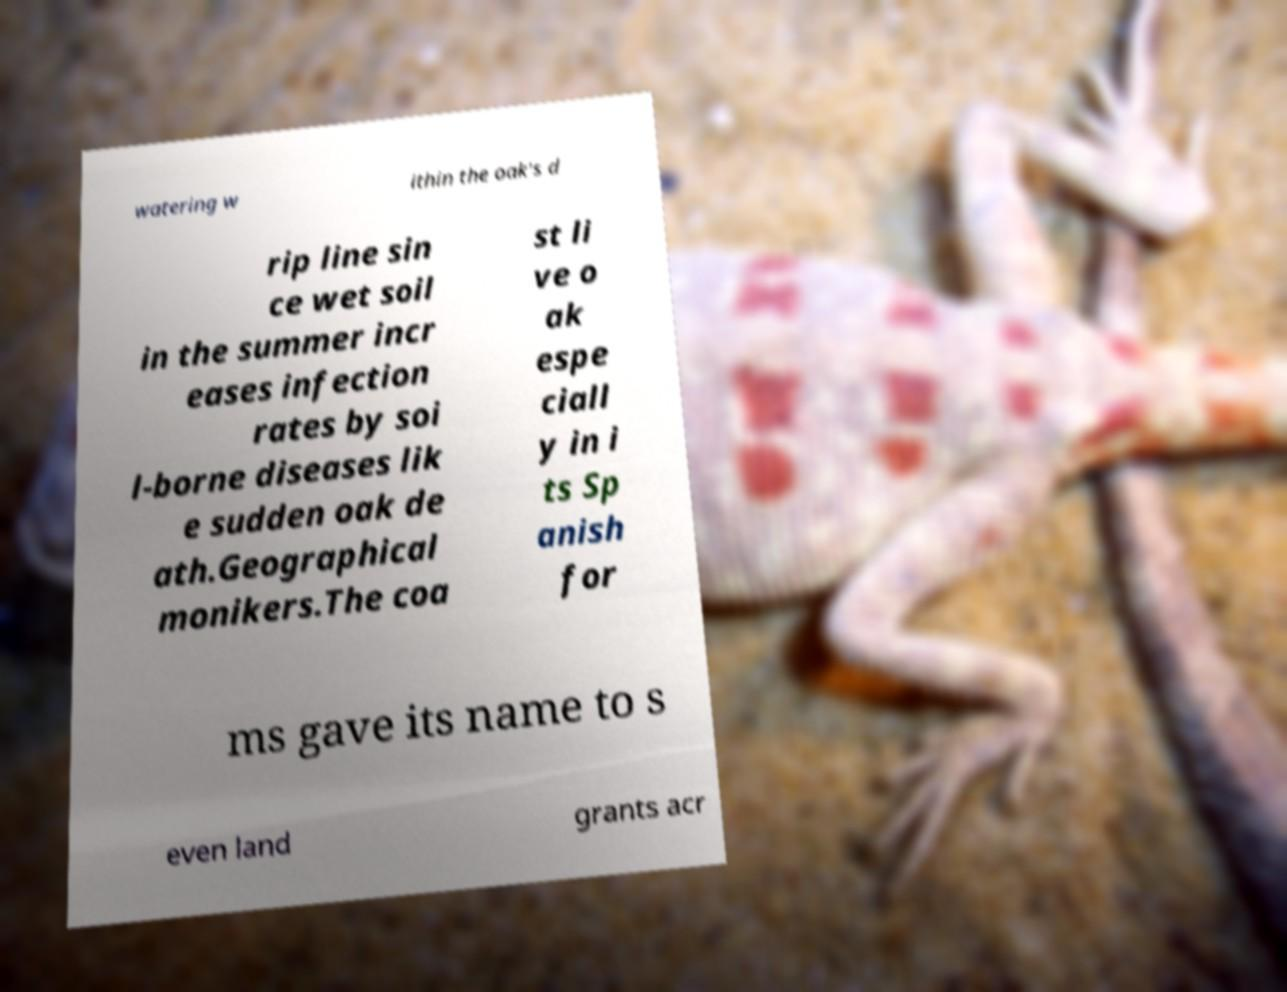For documentation purposes, I need the text within this image transcribed. Could you provide that? watering w ithin the oak's d rip line sin ce wet soil in the summer incr eases infection rates by soi l-borne diseases lik e sudden oak de ath.Geographical monikers.The coa st li ve o ak espe ciall y in i ts Sp anish for ms gave its name to s even land grants acr 